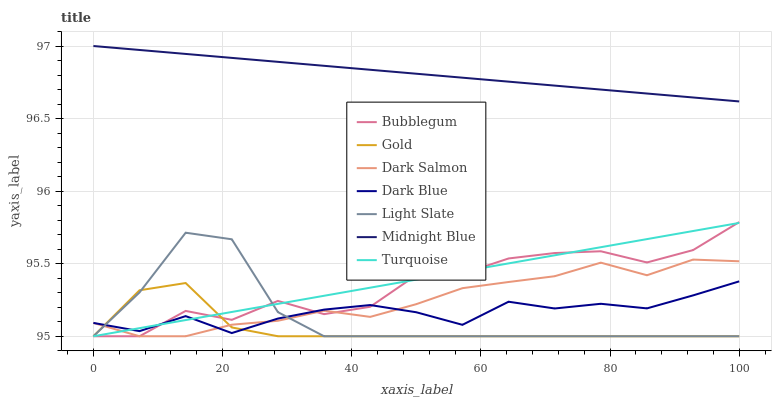Does Gold have the minimum area under the curve?
Answer yes or no. Yes. Does Midnight Blue have the maximum area under the curve?
Answer yes or no. Yes. Does Midnight Blue have the minimum area under the curve?
Answer yes or no. No. Does Gold have the maximum area under the curve?
Answer yes or no. No. Is Turquoise the smoothest?
Answer yes or no. Yes. Is Bubblegum the roughest?
Answer yes or no. Yes. Is Midnight Blue the smoothest?
Answer yes or no. No. Is Midnight Blue the roughest?
Answer yes or no. No. Does Turquoise have the lowest value?
Answer yes or no. Yes. Does Midnight Blue have the lowest value?
Answer yes or no. No. Does Midnight Blue have the highest value?
Answer yes or no. Yes. Does Gold have the highest value?
Answer yes or no. No. Is Dark Blue less than Midnight Blue?
Answer yes or no. Yes. Is Midnight Blue greater than Gold?
Answer yes or no. Yes. Does Dark Blue intersect Dark Salmon?
Answer yes or no. Yes. Is Dark Blue less than Dark Salmon?
Answer yes or no. No. Is Dark Blue greater than Dark Salmon?
Answer yes or no. No. Does Dark Blue intersect Midnight Blue?
Answer yes or no. No. 